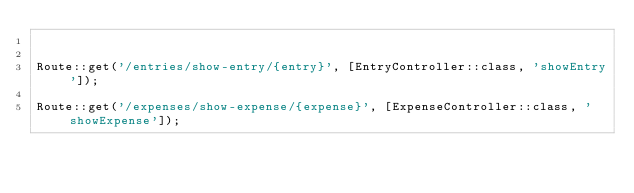Convert code to text. <code><loc_0><loc_0><loc_500><loc_500><_PHP_>

Route::get('/entries/show-entry/{entry}', [EntryController::class, 'showEntry']);

Route::get('/expenses/show-expense/{expense}', [ExpenseController::class, 'showExpense']);
</code> 